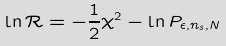<formula> <loc_0><loc_0><loc_500><loc_500>\ln \mathcal { R } = - \frac { 1 } { 2 } \chi ^ { 2 } - \ln P _ { \epsilon , n _ { s } , N }</formula> 